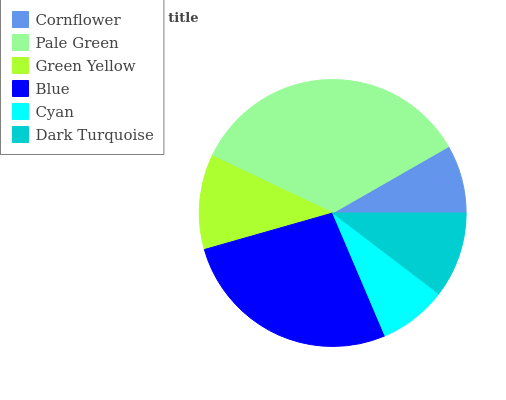Is Cyan the minimum?
Answer yes or no. Yes. Is Pale Green the maximum?
Answer yes or no. Yes. Is Green Yellow the minimum?
Answer yes or no. No. Is Green Yellow the maximum?
Answer yes or no. No. Is Pale Green greater than Green Yellow?
Answer yes or no. Yes. Is Green Yellow less than Pale Green?
Answer yes or no. Yes. Is Green Yellow greater than Pale Green?
Answer yes or no. No. Is Pale Green less than Green Yellow?
Answer yes or no. No. Is Green Yellow the high median?
Answer yes or no. Yes. Is Dark Turquoise the low median?
Answer yes or no. Yes. Is Dark Turquoise the high median?
Answer yes or no. No. Is Cyan the low median?
Answer yes or no. No. 